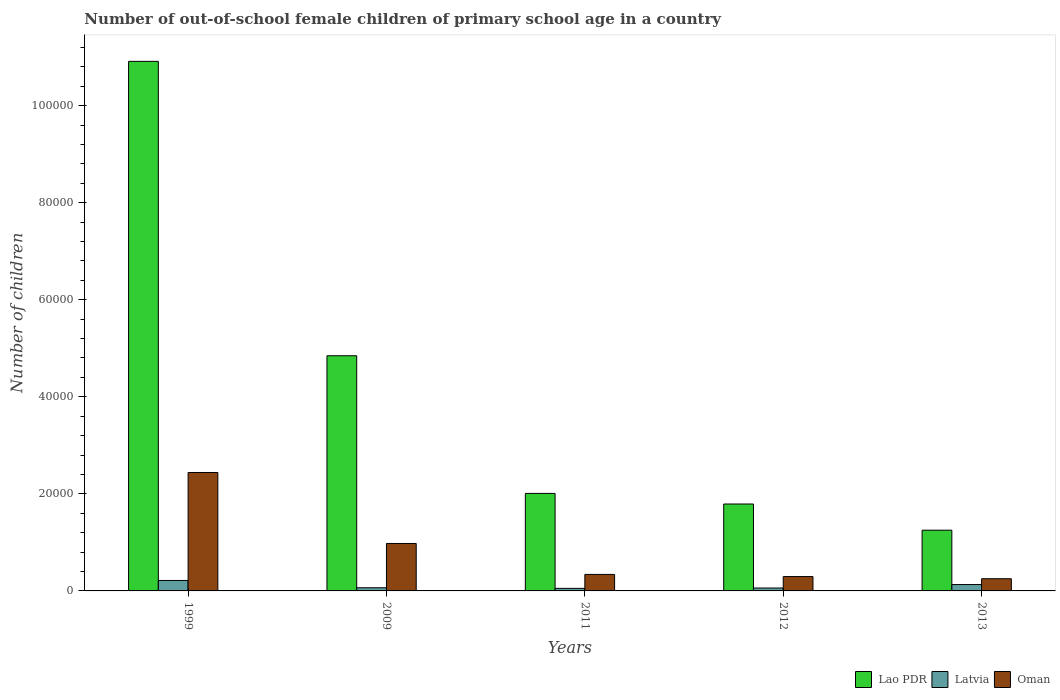Are the number of bars per tick equal to the number of legend labels?
Provide a succinct answer. Yes. In how many cases, is the number of bars for a given year not equal to the number of legend labels?
Keep it short and to the point. 0. What is the number of out-of-school female children in Lao PDR in 2009?
Ensure brevity in your answer.  4.85e+04. Across all years, what is the maximum number of out-of-school female children in Lao PDR?
Give a very brief answer. 1.09e+05. Across all years, what is the minimum number of out-of-school female children in Latvia?
Provide a succinct answer. 527. In which year was the number of out-of-school female children in Oman maximum?
Give a very brief answer. 1999. In which year was the number of out-of-school female children in Oman minimum?
Your answer should be compact. 2013. What is the total number of out-of-school female children in Latvia in the graph?
Provide a succinct answer. 5248. What is the difference between the number of out-of-school female children in Latvia in 1999 and that in 2011?
Give a very brief answer. 1630. What is the difference between the number of out-of-school female children in Latvia in 2011 and the number of out-of-school female children in Lao PDR in 1999?
Make the answer very short. -1.09e+05. What is the average number of out-of-school female children in Lao PDR per year?
Keep it short and to the point. 4.16e+04. In the year 2009, what is the difference between the number of out-of-school female children in Oman and number of out-of-school female children in Lao PDR?
Your response must be concise. -3.87e+04. What is the ratio of the number of out-of-school female children in Latvia in 1999 to that in 2009?
Your answer should be very brief. 3.3. Is the difference between the number of out-of-school female children in Oman in 2009 and 2013 greater than the difference between the number of out-of-school female children in Lao PDR in 2009 and 2013?
Provide a succinct answer. No. What is the difference between the highest and the second highest number of out-of-school female children in Lao PDR?
Provide a succinct answer. 6.07e+04. What is the difference between the highest and the lowest number of out-of-school female children in Lao PDR?
Provide a short and direct response. 9.66e+04. In how many years, is the number of out-of-school female children in Latvia greater than the average number of out-of-school female children in Latvia taken over all years?
Ensure brevity in your answer.  2. Is the sum of the number of out-of-school female children in Lao PDR in 2012 and 2013 greater than the maximum number of out-of-school female children in Latvia across all years?
Make the answer very short. Yes. What does the 2nd bar from the left in 1999 represents?
Offer a very short reply. Latvia. What does the 1st bar from the right in 2013 represents?
Ensure brevity in your answer.  Oman. How many bars are there?
Provide a short and direct response. 15. Are all the bars in the graph horizontal?
Your answer should be very brief. No. What is the difference between two consecutive major ticks on the Y-axis?
Offer a very short reply. 2.00e+04. Does the graph contain grids?
Offer a very short reply. No. What is the title of the graph?
Your answer should be compact. Number of out-of-school female children of primary school age in a country. What is the label or title of the Y-axis?
Provide a short and direct response. Number of children. What is the Number of children of Lao PDR in 1999?
Provide a short and direct response. 1.09e+05. What is the Number of children of Latvia in 1999?
Offer a very short reply. 2157. What is the Number of children in Oman in 1999?
Provide a succinct answer. 2.44e+04. What is the Number of children in Lao PDR in 2009?
Give a very brief answer. 4.85e+04. What is the Number of children of Latvia in 2009?
Offer a very short reply. 653. What is the Number of children of Oman in 2009?
Offer a terse response. 9777. What is the Number of children of Lao PDR in 2011?
Ensure brevity in your answer.  2.01e+04. What is the Number of children of Latvia in 2011?
Your answer should be compact. 527. What is the Number of children of Oman in 2011?
Offer a very short reply. 3401. What is the Number of children of Lao PDR in 2012?
Offer a terse response. 1.79e+04. What is the Number of children in Latvia in 2012?
Offer a terse response. 600. What is the Number of children in Oman in 2012?
Provide a short and direct response. 2958. What is the Number of children in Lao PDR in 2013?
Give a very brief answer. 1.25e+04. What is the Number of children of Latvia in 2013?
Offer a very short reply. 1311. What is the Number of children in Oman in 2013?
Give a very brief answer. 2512. Across all years, what is the maximum Number of children of Lao PDR?
Keep it short and to the point. 1.09e+05. Across all years, what is the maximum Number of children in Latvia?
Offer a terse response. 2157. Across all years, what is the maximum Number of children of Oman?
Make the answer very short. 2.44e+04. Across all years, what is the minimum Number of children in Lao PDR?
Keep it short and to the point. 1.25e+04. Across all years, what is the minimum Number of children of Latvia?
Give a very brief answer. 527. Across all years, what is the minimum Number of children in Oman?
Provide a succinct answer. 2512. What is the total Number of children in Lao PDR in the graph?
Make the answer very short. 2.08e+05. What is the total Number of children of Latvia in the graph?
Give a very brief answer. 5248. What is the total Number of children in Oman in the graph?
Ensure brevity in your answer.  4.31e+04. What is the difference between the Number of children in Lao PDR in 1999 and that in 2009?
Your answer should be compact. 6.07e+04. What is the difference between the Number of children of Latvia in 1999 and that in 2009?
Your response must be concise. 1504. What is the difference between the Number of children in Oman in 1999 and that in 2009?
Offer a terse response. 1.46e+04. What is the difference between the Number of children of Lao PDR in 1999 and that in 2011?
Give a very brief answer. 8.90e+04. What is the difference between the Number of children of Latvia in 1999 and that in 2011?
Your response must be concise. 1630. What is the difference between the Number of children of Oman in 1999 and that in 2011?
Your answer should be compact. 2.10e+04. What is the difference between the Number of children of Lao PDR in 1999 and that in 2012?
Offer a terse response. 9.12e+04. What is the difference between the Number of children in Latvia in 1999 and that in 2012?
Provide a succinct answer. 1557. What is the difference between the Number of children in Oman in 1999 and that in 2012?
Your response must be concise. 2.14e+04. What is the difference between the Number of children of Lao PDR in 1999 and that in 2013?
Ensure brevity in your answer.  9.66e+04. What is the difference between the Number of children of Latvia in 1999 and that in 2013?
Your response must be concise. 846. What is the difference between the Number of children in Oman in 1999 and that in 2013?
Offer a very short reply. 2.19e+04. What is the difference between the Number of children of Lao PDR in 2009 and that in 2011?
Offer a very short reply. 2.84e+04. What is the difference between the Number of children of Latvia in 2009 and that in 2011?
Ensure brevity in your answer.  126. What is the difference between the Number of children in Oman in 2009 and that in 2011?
Your answer should be very brief. 6376. What is the difference between the Number of children in Lao PDR in 2009 and that in 2012?
Provide a short and direct response. 3.06e+04. What is the difference between the Number of children of Oman in 2009 and that in 2012?
Provide a succinct answer. 6819. What is the difference between the Number of children of Lao PDR in 2009 and that in 2013?
Offer a terse response. 3.59e+04. What is the difference between the Number of children in Latvia in 2009 and that in 2013?
Your answer should be very brief. -658. What is the difference between the Number of children in Oman in 2009 and that in 2013?
Keep it short and to the point. 7265. What is the difference between the Number of children of Lao PDR in 2011 and that in 2012?
Offer a very short reply. 2184. What is the difference between the Number of children of Latvia in 2011 and that in 2012?
Your answer should be very brief. -73. What is the difference between the Number of children of Oman in 2011 and that in 2012?
Provide a succinct answer. 443. What is the difference between the Number of children in Lao PDR in 2011 and that in 2013?
Keep it short and to the point. 7579. What is the difference between the Number of children of Latvia in 2011 and that in 2013?
Offer a terse response. -784. What is the difference between the Number of children in Oman in 2011 and that in 2013?
Your answer should be compact. 889. What is the difference between the Number of children in Lao PDR in 2012 and that in 2013?
Your response must be concise. 5395. What is the difference between the Number of children of Latvia in 2012 and that in 2013?
Keep it short and to the point. -711. What is the difference between the Number of children in Oman in 2012 and that in 2013?
Make the answer very short. 446. What is the difference between the Number of children in Lao PDR in 1999 and the Number of children in Latvia in 2009?
Keep it short and to the point. 1.08e+05. What is the difference between the Number of children in Lao PDR in 1999 and the Number of children in Oman in 2009?
Offer a terse response. 9.94e+04. What is the difference between the Number of children of Latvia in 1999 and the Number of children of Oman in 2009?
Provide a succinct answer. -7620. What is the difference between the Number of children of Lao PDR in 1999 and the Number of children of Latvia in 2011?
Offer a very short reply. 1.09e+05. What is the difference between the Number of children in Lao PDR in 1999 and the Number of children in Oman in 2011?
Give a very brief answer. 1.06e+05. What is the difference between the Number of children of Latvia in 1999 and the Number of children of Oman in 2011?
Make the answer very short. -1244. What is the difference between the Number of children of Lao PDR in 1999 and the Number of children of Latvia in 2012?
Give a very brief answer. 1.09e+05. What is the difference between the Number of children in Lao PDR in 1999 and the Number of children in Oman in 2012?
Your response must be concise. 1.06e+05. What is the difference between the Number of children of Latvia in 1999 and the Number of children of Oman in 2012?
Make the answer very short. -801. What is the difference between the Number of children in Lao PDR in 1999 and the Number of children in Latvia in 2013?
Ensure brevity in your answer.  1.08e+05. What is the difference between the Number of children of Lao PDR in 1999 and the Number of children of Oman in 2013?
Your answer should be very brief. 1.07e+05. What is the difference between the Number of children in Latvia in 1999 and the Number of children in Oman in 2013?
Keep it short and to the point. -355. What is the difference between the Number of children of Lao PDR in 2009 and the Number of children of Latvia in 2011?
Offer a terse response. 4.79e+04. What is the difference between the Number of children in Lao PDR in 2009 and the Number of children in Oman in 2011?
Provide a short and direct response. 4.51e+04. What is the difference between the Number of children of Latvia in 2009 and the Number of children of Oman in 2011?
Offer a very short reply. -2748. What is the difference between the Number of children of Lao PDR in 2009 and the Number of children of Latvia in 2012?
Provide a succinct answer. 4.79e+04. What is the difference between the Number of children in Lao PDR in 2009 and the Number of children in Oman in 2012?
Ensure brevity in your answer.  4.55e+04. What is the difference between the Number of children of Latvia in 2009 and the Number of children of Oman in 2012?
Provide a succinct answer. -2305. What is the difference between the Number of children in Lao PDR in 2009 and the Number of children in Latvia in 2013?
Make the answer very short. 4.71e+04. What is the difference between the Number of children in Lao PDR in 2009 and the Number of children in Oman in 2013?
Ensure brevity in your answer.  4.59e+04. What is the difference between the Number of children of Latvia in 2009 and the Number of children of Oman in 2013?
Offer a very short reply. -1859. What is the difference between the Number of children in Lao PDR in 2011 and the Number of children in Latvia in 2012?
Provide a short and direct response. 1.95e+04. What is the difference between the Number of children in Lao PDR in 2011 and the Number of children in Oman in 2012?
Offer a very short reply. 1.71e+04. What is the difference between the Number of children of Latvia in 2011 and the Number of children of Oman in 2012?
Provide a short and direct response. -2431. What is the difference between the Number of children in Lao PDR in 2011 and the Number of children in Latvia in 2013?
Offer a very short reply. 1.88e+04. What is the difference between the Number of children in Lao PDR in 2011 and the Number of children in Oman in 2013?
Provide a succinct answer. 1.76e+04. What is the difference between the Number of children of Latvia in 2011 and the Number of children of Oman in 2013?
Provide a short and direct response. -1985. What is the difference between the Number of children in Lao PDR in 2012 and the Number of children in Latvia in 2013?
Make the answer very short. 1.66e+04. What is the difference between the Number of children of Lao PDR in 2012 and the Number of children of Oman in 2013?
Your answer should be very brief. 1.54e+04. What is the difference between the Number of children of Latvia in 2012 and the Number of children of Oman in 2013?
Provide a short and direct response. -1912. What is the average Number of children in Lao PDR per year?
Your response must be concise. 4.16e+04. What is the average Number of children of Latvia per year?
Offer a very short reply. 1049.6. What is the average Number of children of Oman per year?
Offer a terse response. 8610.2. In the year 1999, what is the difference between the Number of children of Lao PDR and Number of children of Latvia?
Offer a very short reply. 1.07e+05. In the year 1999, what is the difference between the Number of children in Lao PDR and Number of children in Oman?
Ensure brevity in your answer.  8.47e+04. In the year 1999, what is the difference between the Number of children of Latvia and Number of children of Oman?
Ensure brevity in your answer.  -2.22e+04. In the year 2009, what is the difference between the Number of children in Lao PDR and Number of children in Latvia?
Ensure brevity in your answer.  4.78e+04. In the year 2009, what is the difference between the Number of children in Lao PDR and Number of children in Oman?
Your response must be concise. 3.87e+04. In the year 2009, what is the difference between the Number of children of Latvia and Number of children of Oman?
Your answer should be very brief. -9124. In the year 2011, what is the difference between the Number of children of Lao PDR and Number of children of Latvia?
Provide a short and direct response. 1.96e+04. In the year 2011, what is the difference between the Number of children in Lao PDR and Number of children in Oman?
Offer a very short reply. 1.67e+04. In the year 2011, what is the difference between the Number of children in Latvia and Number of children in Oman?
Your response must be concise. -2874. In the year 2012, what is the difference between the Number of children in Lao PDR and Number of children in Latvia?
Give a very brief answer. 1.73e+04. In the year 2012, what is the difference between the Number of children in Lao PDR and Number of children in Oman?
Ensure brevity in your answer.  1.50e+04. In the year 2012, what is the difference between the Number of children in Latvia and Number of children in Oman?
Give a very brief answer. -2358. In the year 2013, what is the difference between the Number of children in Lao PDR and Number of children in Latvia?
Keep it short and to the point. 1.12e+04. In the year 2013, what is the difference between the Number of children in Lao PDR and Number of children in Oman?
Ensure brevity in your answer.  1.00e+04. In the year 2013, what is the difference between the Number of children of Latvia and Number of children of Oman?
Keep it short and to the point. -1201. What is the ratio of the Number of children of Lao PDR in 1999 to that in 2009?
Give a very brief answer. 2.25. What is the ratio of the Number of children in Latvia in 1999 to that in 2009?
Provide a succinct answer. 3.3. What is the ratio of the Number of children of Oman in 1999 to that in 2009?
Offer a very short reply. 2.5. What is the ratio of the Number of children in Lao PDR in 1999 to that in 2011?
Your answer should be compact. 5.43. What is the ratio of the Number of children in Latvia in 1999 to that in 2011?
Give a very brief answer. 4.09. What is the ratio of the Number of children of Oman in 1999 to that in 2011?
Your answer should be compact. 7.18. What is the ratio of the Number of children of Lao PDR in 1999 to that in 2012?
Provide a succinct answer. 6.09. What is the ratio of the Number of children in Latvia in 1999 to that in 2012?
Keep it short and to the point. 3.6. What is the ratio of the Number of children of Oman in 1999 to that in 2012?
Ensure brevity in your answer.  8.25. What is the ratio of the Number of children in Lao PDR in 1999 to that in 2013?
Give a very brief answer. 8.72. What is the ratio of the Number of children in Latvia in 1999 to that in 2013?
Offer a terse response. 1.65. What is the ratio of the Number of children in Oman in 1999 to that in 2013?
Your answer should be compact. 9.71. What is the ratio of the Number of children of Lao PDR in 2009 to that in 2011?
Ensure brevity in your answer.  2.41. What is the ratio of the Number of children of Latvia in 2009 to that in 2011?
Make the answer very short. 1.24. What is the ratio of the Number of children in Oman in 2009 to that in 2011?
Offer a terse response. 2.87. What is the ratio of the Number of children in Lao PDR in 2009 to that in 2012?
Give a very brief answer. 2.71. What is the ratio of the Number of children of Latvia in 2009 to that in 2012?
Keep it short and to the point. 1.09. What is the ratio of the Number of children in Oman in 2009 to that in 2012?
Provide a succinct answer. 3.31. What is the ratio of the Number of children in Lao PDR in 2009 to that in 2013?
Your answer should be compact. 3.87. What is the ratio of the Number of children of Latvia in 2009 to that in 2013?
Your answer should be very brief. 0.5. What is the ratio of the Number of children in Oman in 2009 to that in 2013?
Give a very brief answer. 3.89. What is the ratio of the Number of children of Lao PDR in 2011 to that in 2012?
Make the answer very short. 1.12. What is the ratio of the Number of children of Latvia in 2011 to that in 2012?
Offer a terse response. 0.88. What is the ratio of the Number of children in Oman in 2011 to that in 2012?
Offer a terse response. 1.15. What is the ratio of the Number of children of Lao PDR in 2011 to that in 2013?
Provide a short and direct response. 1.61. What is the ratio of the Number of children in Latvia in 2011 to that in 2013?
Your answer should be compact. 0.4. What is the ratio of the Number of children in Oman in 2011 to that in 2013?
Your answer should be compact. 1.35. What is the ratio of the Number of children of Lao PDR in 2012 to that in 2013?
Your answer should be compact. 1.43. What is the ratio of the Number of children of Latvia in 2012 to that in 2013?
Offer a terse response. 0.46. What is the ratio of the Number of children of Oman in 2012 to that in 2013?
Make the answer very short. 1.18. What is the difference between the highest and the second highest Number of children of Lao PDR?
Keep it short and to the point. 6.07e+04. What is the difference between the highest and the second highest Number of children of Latvia?
Provide a short and direct response. 846. What is the difference between the highest and the second highest Number of children in Oman?
Provide a short and direct response. 1.46e+04. What is the difference between the highest and the lowest Number of children in Lao PDR?
Make the answer very short. 9.66e+04. What is the difference between the highest and the lowest Number of children of Latvia?
Provide a succinct answer. 1630. What is the difference between the highest and the lowest Number of children in Oman?
Offer a terse response. 2.19e+04. 